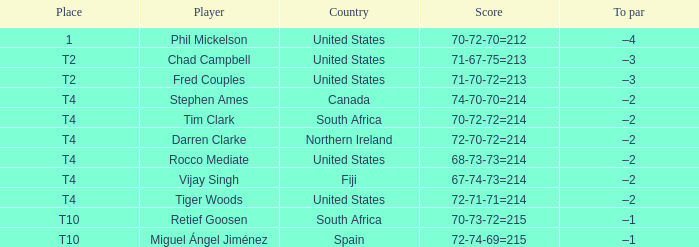What country is Chad Campbell from? United States. 